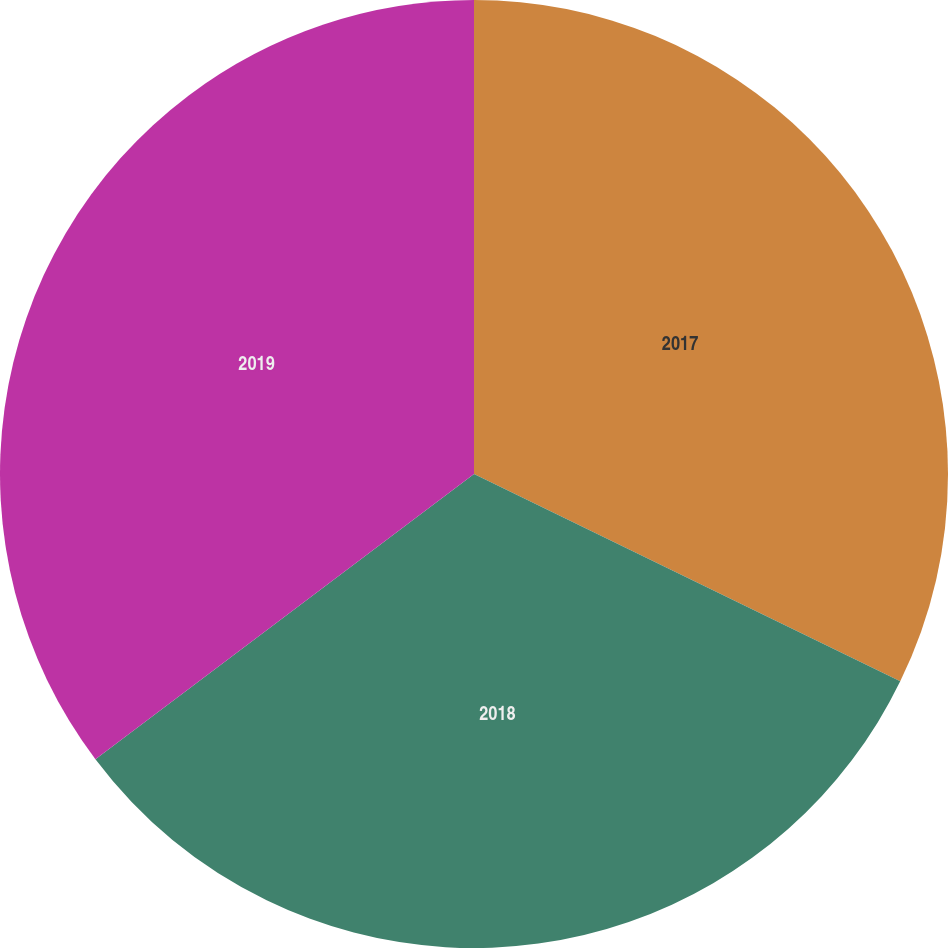Convert chart to OTSL. <chart><loc_0><loc_0><loc_500><loc_500><pie_chart><fcel>2017<fcel>2018<fcel>2019<nl><fcel>32.21%<fcel>32.52%<fcel>35.28%<nl></chart> 